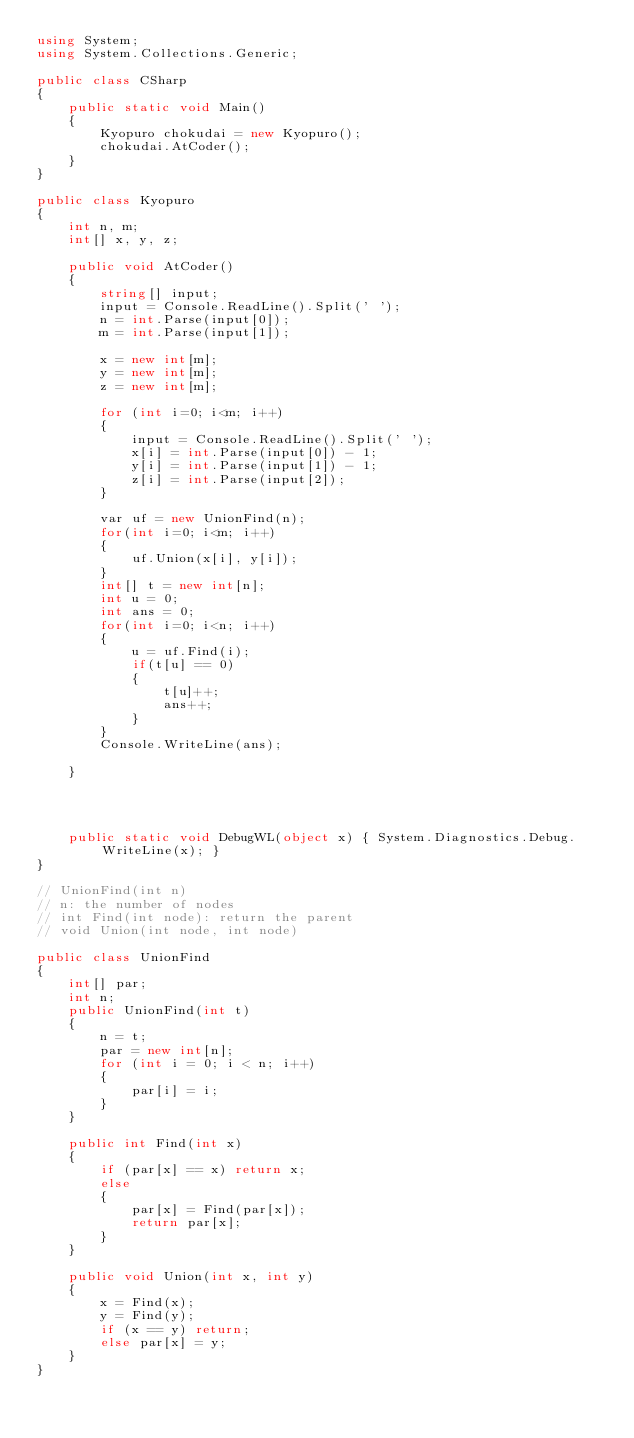Convert code to text. <code><loc_0><loc_0><loc_500><loc_500><_C#_>using System;
using System.Collections.Generic;

public class CSharp
{
    public static void Main()
    {
        Kyopuro chokudai = new Kyopuro();
        chokudai.AtCoder();
    }
}

public class Kyopuro
{
    int n, m;
    int[] x, y, z;

    public void AtCoder()
    {
        string[] input;
        input = Console.ReadLine().Split(' ');
        n = int.Parse(input[0]);
        m = int.Parse(input[1]);

        x = new int[m];
        y = new int[m];
        z = new int[m];

        for (int i=0; i<m; i++)
        {
            input = Console.ReadLine().Split(' ');
            x[i] = int.Parse(input[0]) - 1;
            y[i] = int.Parse(input[1]) - 1;
            z[i] = int.Parse(input[2]);
        }

        var uf = new UnionFind(n);
        for(int i=0; i<m; i++)
        {
            uf.Union(x[i], y[i]);
        }
        int[] t = new int[n];
        int u = 0;
        int ans = 0;
        for(int i=0; i<n; i++)
        {
            u = uf.Find(i);
            if(t[u] == 0)
            {
                t[u]++;
                ans++;
            }
        }
        Console.WriteLine(ans);

    }


    

    public static void DebugWL(object x) { System.Diagnostics.Debug.WriteLine(x); }
}

// UnionFind(int n)
// n: the number of nodes
// int Find(int node): return the parent
// void Union(int node, int node)

public class UnionFind
{
    int[] par;
    int n;
    public UnionFind(int t)
    {
        n = t;
        par = new int[n];
        for (int i = 0; i < n; i++)
        {
            par[i] = i;
        }
    }

    public int Find(int x)
    {
        if (par[x] == x) return x;
        else
        {
            par[x] = Find(par[x]);
            return par[x];
        }
    }

    public void Union(int x, int y)
    {
        x = Find(x);
        y = Find(y);
        if (x == y) return;
        else par[x] = y;
    }
}
</code> 